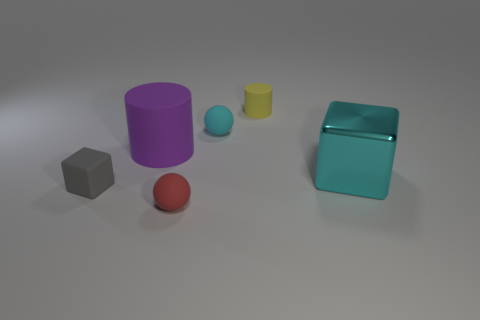Is there anything else that has the same material as the large cyan thing?
Make the answer very short. No. Is the number of metal blocks greater than the number of large objects?
Provide a short and direct response. No. What number of other objects are the same material as the tiny gray block?
Keep it short and to the point. 4. What number of cyan rubber spheres are to the right of the red thing that is on the left side of the small ball behind the large shiny thing?
Provide a short and direct response. 1. What number of rubber objects are yellow objects or cylinders?
Give a very brief answer. 2. There is a cylinder that is in front of the cyan object that is left of the small yellow cylinder; what size is it?
Offer a very short reply. Large. There is a block right of the red rubber thing; is it the same color as the rubber sphere behind the small red rubber ball?
Keep it short and to the point. Yes. What is the color of the object that is both on the left side of the cyan rubber sphere and behind the gray rubber cube?
Your answer should be very brief. Purple. Do the small yellow cylinder and the gray cube have the same material?
Offer a terse response. Yes. How many large things are either purple things or rubber cylinders?
Ensure brevity in your answer.  1. 